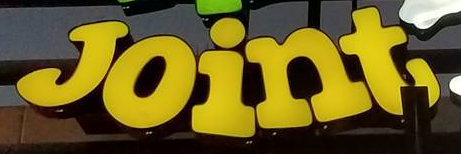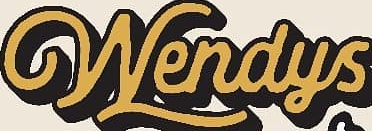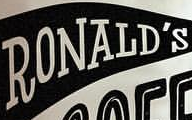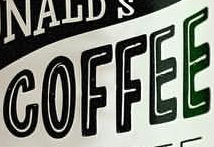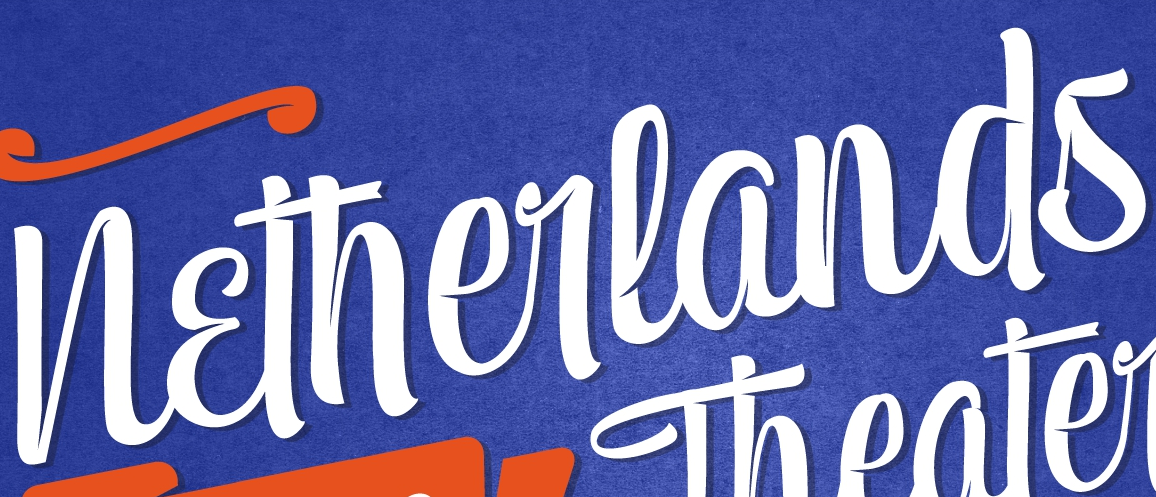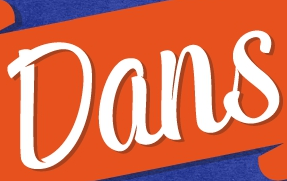Read the text content from these images in order, separated by a semicolon. Joint; Wendys; RONALD'S; COFFEE; Netherlands; Dans 